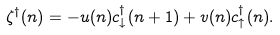<formula> <loc_0><loc_0><loc_500><loc_500>\zeta ^ { \dagger } ( n ) = - u ( n ) c _ { \downarrow } ^ { \dagger } ( n + 1 ) + v ( n ) c _ { \uparrow } ^ { \dagger } ( n ) .</formula> 